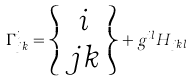<formula> <loc_0><loc_0><loc_500><loc_500>\Gamma ^ { i } _ { j k } = \left \{ \begin{array} { c } i \\ j k \end{array} \right \} + g ^ { i l } H _ { j k l }</formula> 